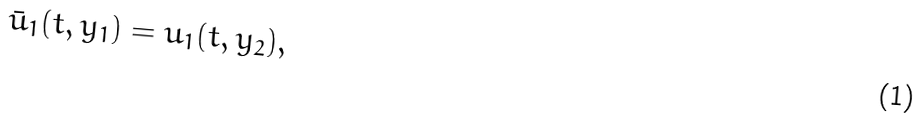Convert formula to latex. <formula><loc_0><loc_0><loc_500><loc_500>\bar { u } _ { 1 } ( t , y _ { 1 } ) = u _ { 1 } ( t , y _ { 2 } ) ,</formula> 